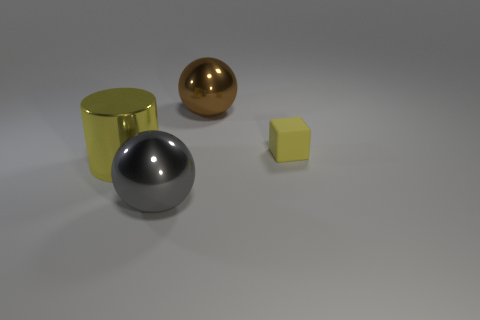Is there any other thing that has the same material as the tiny yellow cube?
Ensure brevity in your answer.  No. Is the size of the yellow cylinder the same as the brown object?
Give a very brief answer. Yes. How many large objects are either yellow metallic cylinders or brown matte blocks?
Keep it short and to the point. 1. How many gray spheres are right of the gray metallic ball?
Offer a terse response. 0. Is the number of matte blocks left of the large brown sphere greater than the number of small matte things?
Make the answer very short. No. There is a big brown thing that is the same material as the yellow cylinder; what is its shape?
Offer a terse response. Sphere. There is a metal ball behind the big metal cylinder left of the small yellow thing; what color is it?
Give a very brief answer. Brown. Does the matte thing have the same shape as the yellow shiny thing?
Keep it short and to the point. No. What material is the other big object that is the same shape as the large gray metallic thing?
Offer a terse response. Metal. There is a large shiny ball behind the large shiny ball that is in front of the small yellow rubber object; are there any big shiny objects in front of it?
Ensure brevity in your answer.  Yes. 